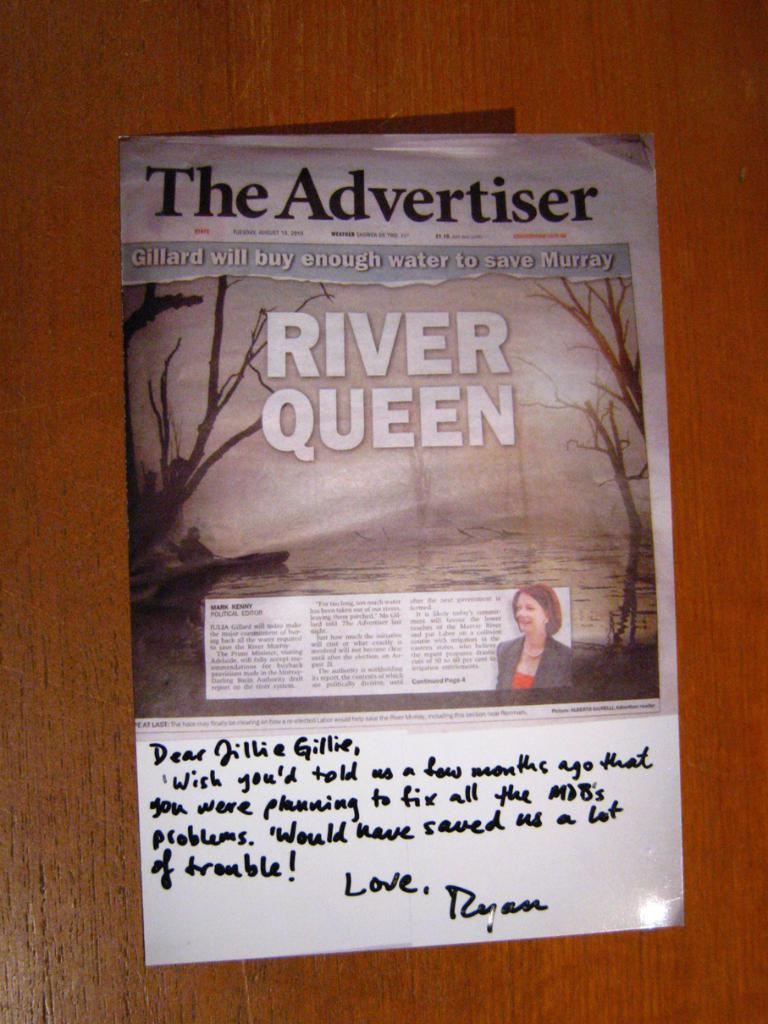What is present on the wooden surface in the image? There is a poster on the wooden surface in the image. What is depicted on the poster? The poster contains an image of trees and a picture of a lady. Is there any text on the poster? Yes, there is text on the poster. Can you see any cracks in the image of the lady on the poster? There are no cracks visible in the image of the lady on the poster, as it is a flat, two-dimensional representation. 